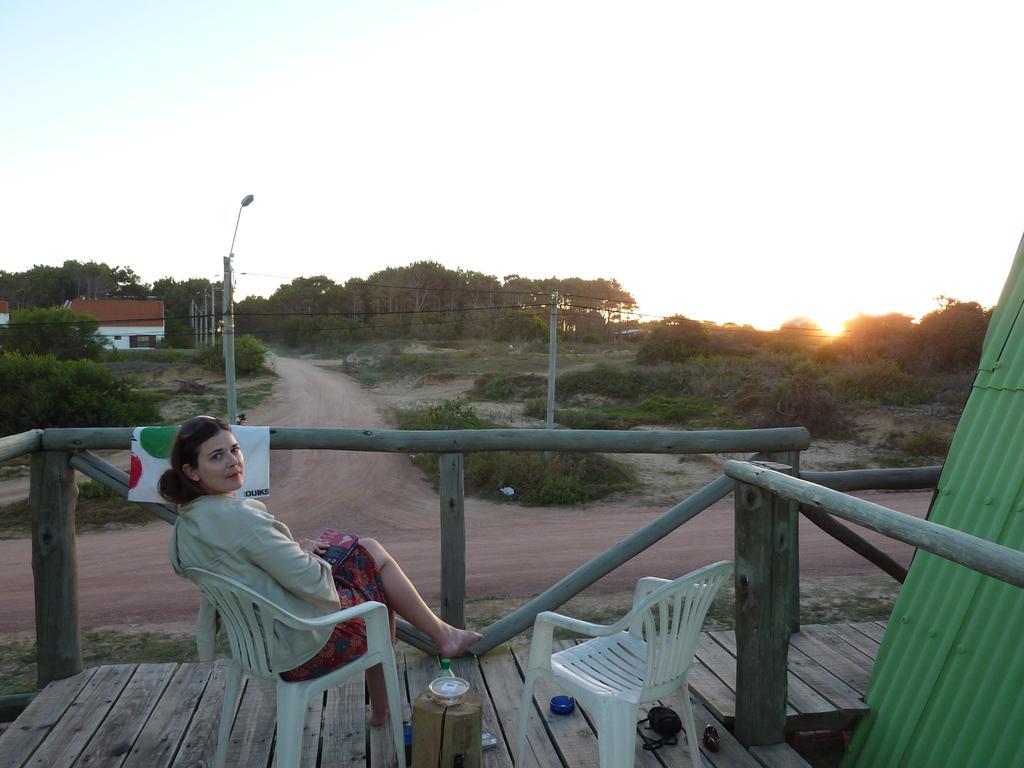Could you give a brief overview of what you see in this image? In the picture I can see a woman sitting on a plastic chair and she is holding a book. I can see the plastic chairs and a small wooden log on the wooden floor. There is a rake metal on the bottom right side. In the background, I can see the trees, electric poles, a light pole and a house. I can see the sunshine in the sky. 